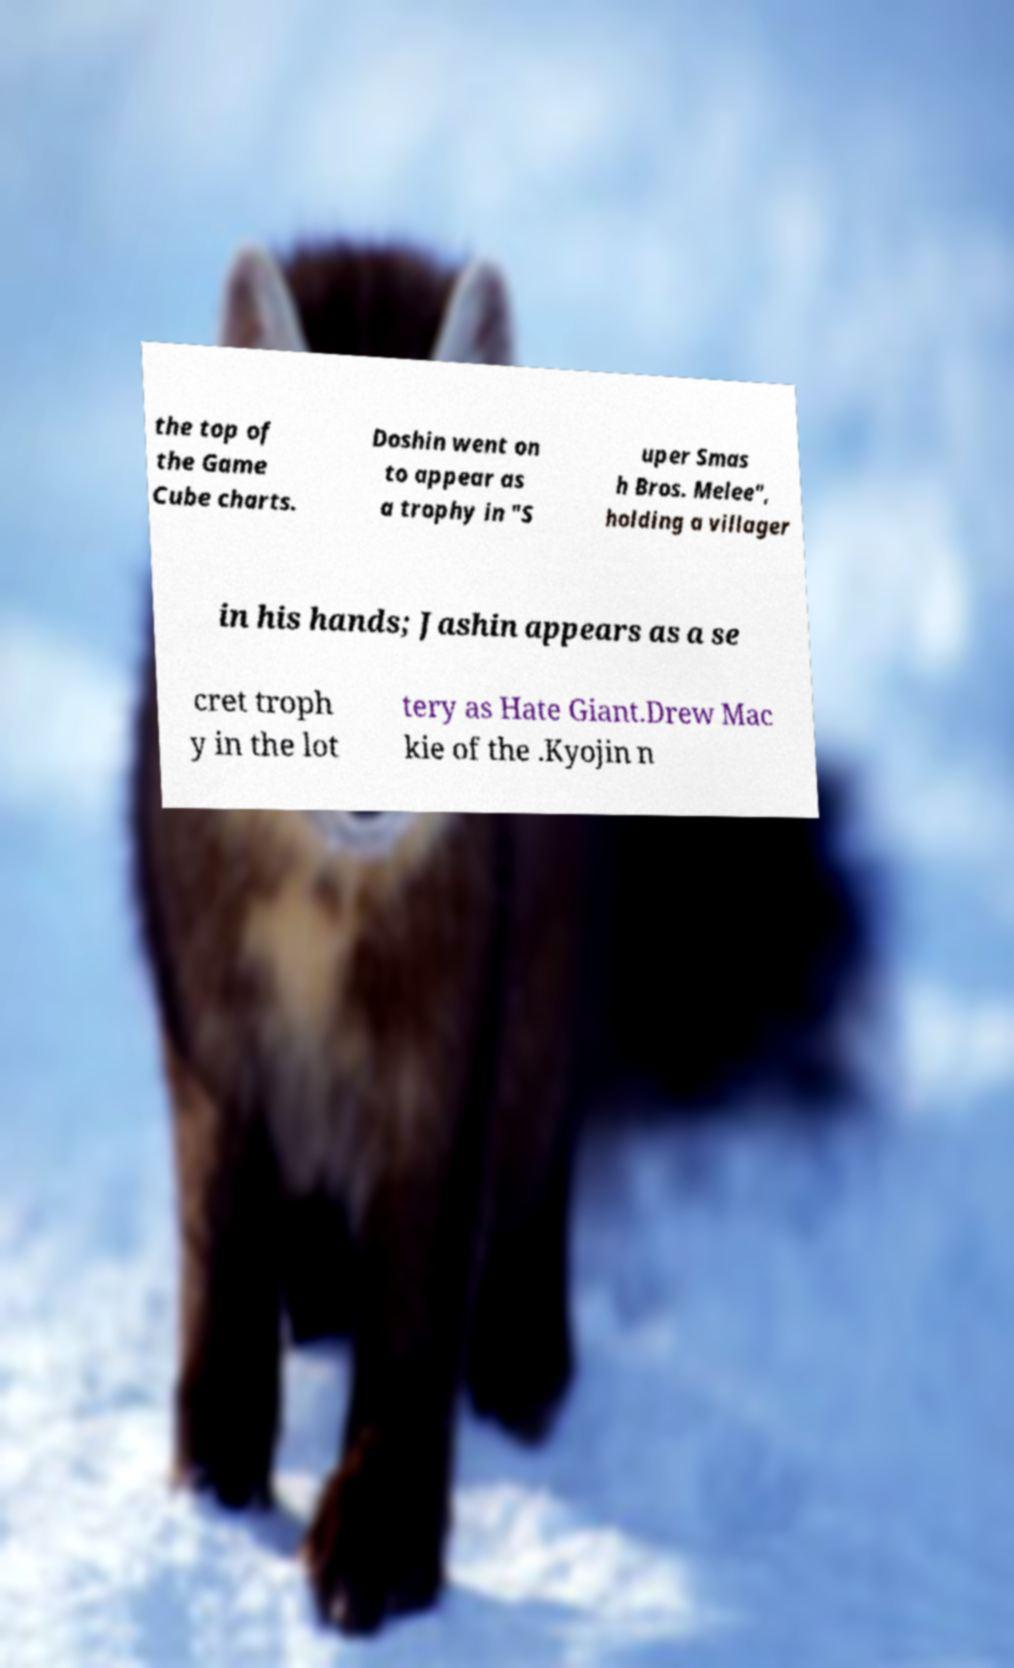There's text embedded in this image that I need extracted. Can you transcribe it verbatim? the top of the Game Cube charts. Doshin went on to appear as a trophy in "S uper Smas h Bros. Melee", holding a villager in his hands; Jashin appears as a se cret troph y in the lot tery as Hate Giant.Drew Mac kie of the .Kyojin n 